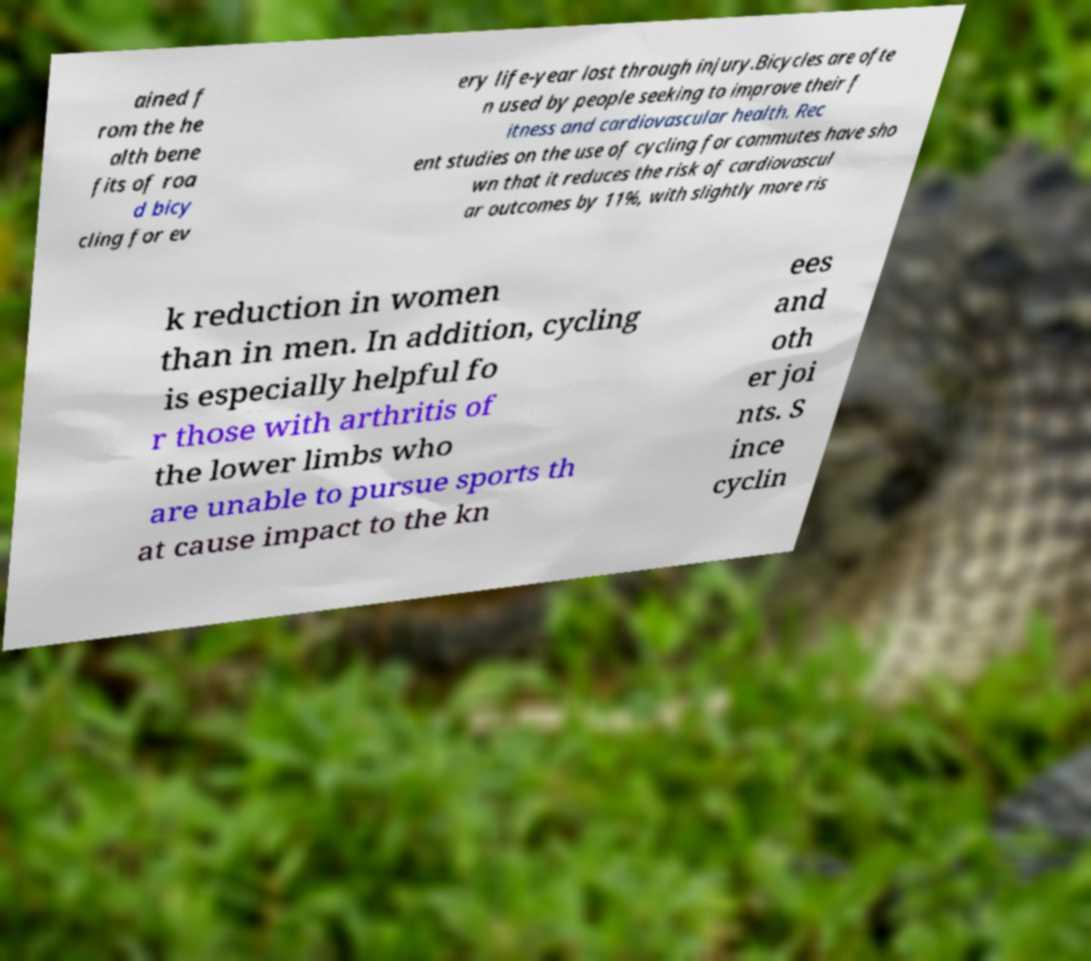Can you read and provide the text displayed in the image?This photo seems to have some interesting text. Can you extract and type it out for me? ained f rom the he alth bene fits of roa d bicy cling for ev ery life-year lost through injury.Bicycles are ofte n used by people seeking to improve their f itness and cardiovascular health. Rec ent studies on the use of cycling for commutes have sho wn that it reduces the risk of cardiovascul ar outcomes by 11%, with slightly more ris k reduction in women than in men. In addition, cycling is especially helpful fo r those with arthritis of the lower limbs who are unable to pursue sports th at cause impact to the kn ees and oth er joi nts. S ince cyclin 